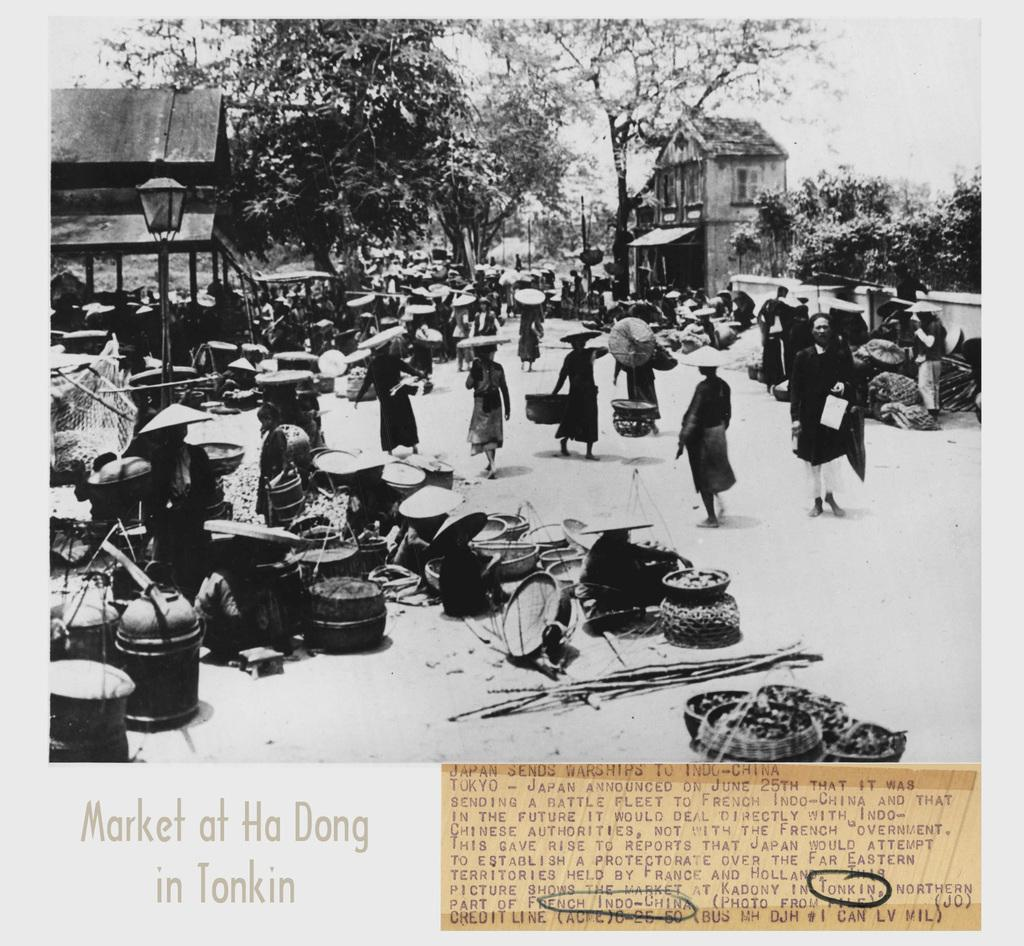Provide a one-sentence caption for the provided image. a black and white image of people and pots at the market at Ha Dong in Tonkin. 